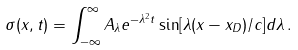Convert formula to latex. <formula><loc_0><loc_0><loc_500><loc_500>\sigma ( x , t ) = \int _ { - \infty } ^ { \infty } A _ { \lambda } e ^ { - \lambda ^ { 2 } t } \sin [ \lambda ( x - x _ { D } ) / c ] d \lambda \, .</formula> 